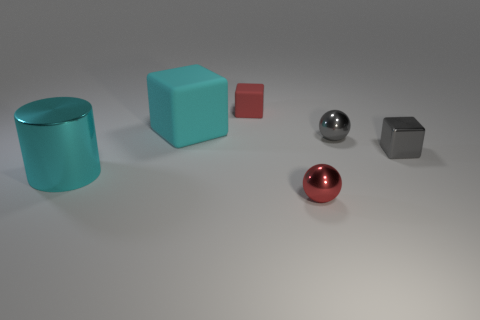There is a tiny red object that is in front of the object behind the cyan cube; what is its shape?
Ensure brevity in your answer.  Sphere. Is there a small cyan cube that has the same material as the gray block?
Offer a very short reply. No. What size is the shiny thing that is the same color as the small matte object?
Ensure brevity in your answer.  Small. What number of blue things are either metallic cubes or blocks?
Ensure brevity in your answer.  0. Is there a metallic thing that has the same color as the big block?
Give a very brief answer. Yes. What size is the red thing that is made of the same material as the big cyan cylinder?
Offer a terse response. Small. How many cylinders are large shiny things or large cyan matte objects?
Offer a terse response. 1. Are there more gray shiny spheres than matte blocks?
Ensure brevity in your answer.  No. What number of other balls are the same size as the red metal sphere?
Ensure brevity in your answer.  1. The shiny object that is the same color as the shiny cube is what shape?
Offer a terse response. Sphere. 